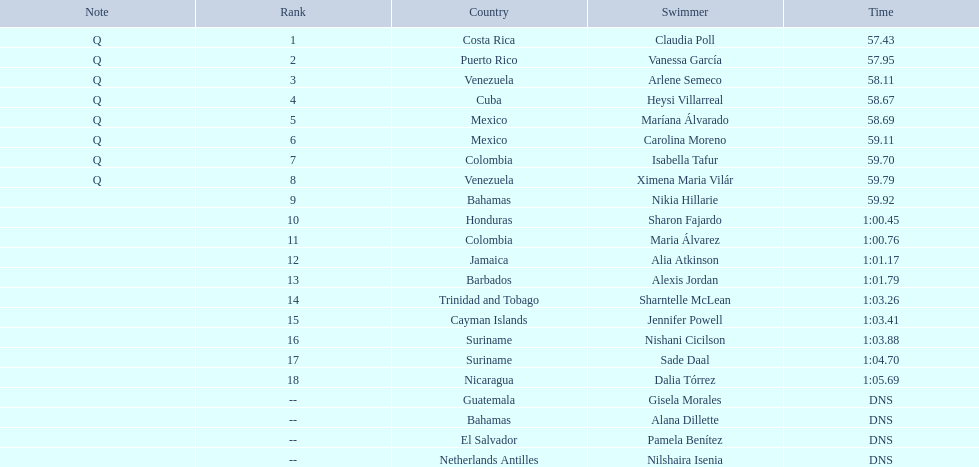Would you be able to parse every entry in this table? {'header': ['Note', 'Rank', 'Country', 'Swimmer', 'Time'], 'rows': [['Q', '1', 'Costa Rica', 'Claudia Poll', '57.43'], ['Q', '2', 'Puerto Rico', 'Vanessa García', '57.95'], ['Q', '3', 'Venezuela', 'Arlene Semeco', '58.11'], ['Q', '4', 'Cuba', 'Heysi Villarreal', '58.67'], ['Q', '5', 'Mexico', 'Maríana Álvarado', '58.69'], ['Q', '6', 'Mexico', 'Carolina Moreno', '59.11'], ['Q', '7', 'Colombia', 'Isabella Tafur', '59.70'], ['Q', '8', 'Venezuela', 'Ximena Maria Vilár', '59.79'], ['', '9', 'Bahamas', 'Nikia Hillarie', '59.92'], ['', '10', 'Honduras', 'Sharon Fajardo', '1:00.45'], ['', '11', 'Colombia', 'Maria Álvarez', '1:00.76'], ['', '12', 'Jamaica', 'Alia Atkinson', '1:01.17'], ['', '13', 'Barbados', 'Alexis Jordan', '1:01.79'], ['', '14', 'Trinidad and Tobago', 'Sharntelle McLean', '1:03.26'], ['', '15', 'Cayman Islands', 'Jennifer Powell', '1:03.41'], ['', '16', 'Suriname', 'Nishani Cicilson', '1:03.88'], ['', '17', 'Suriname', 'Sade Daal', '1:04.70'], ['', '18', 'Nicaragua', 'Dalia Tórrez', '1:05.69'], ['', '--', 'Guatemala', 'Gisela Morales', 'DNS'], ['', '--', 'Bahamas', 'Alana Dillette', 'DNS'], ['', '--', 'El Salvador', 'Pamela Benítez', 'DNS'], ['', '--', 'Netherlands Antilles', 'Nilshaira Isenia', 'DNS']]} How many swimmers are from mexico? 2. 